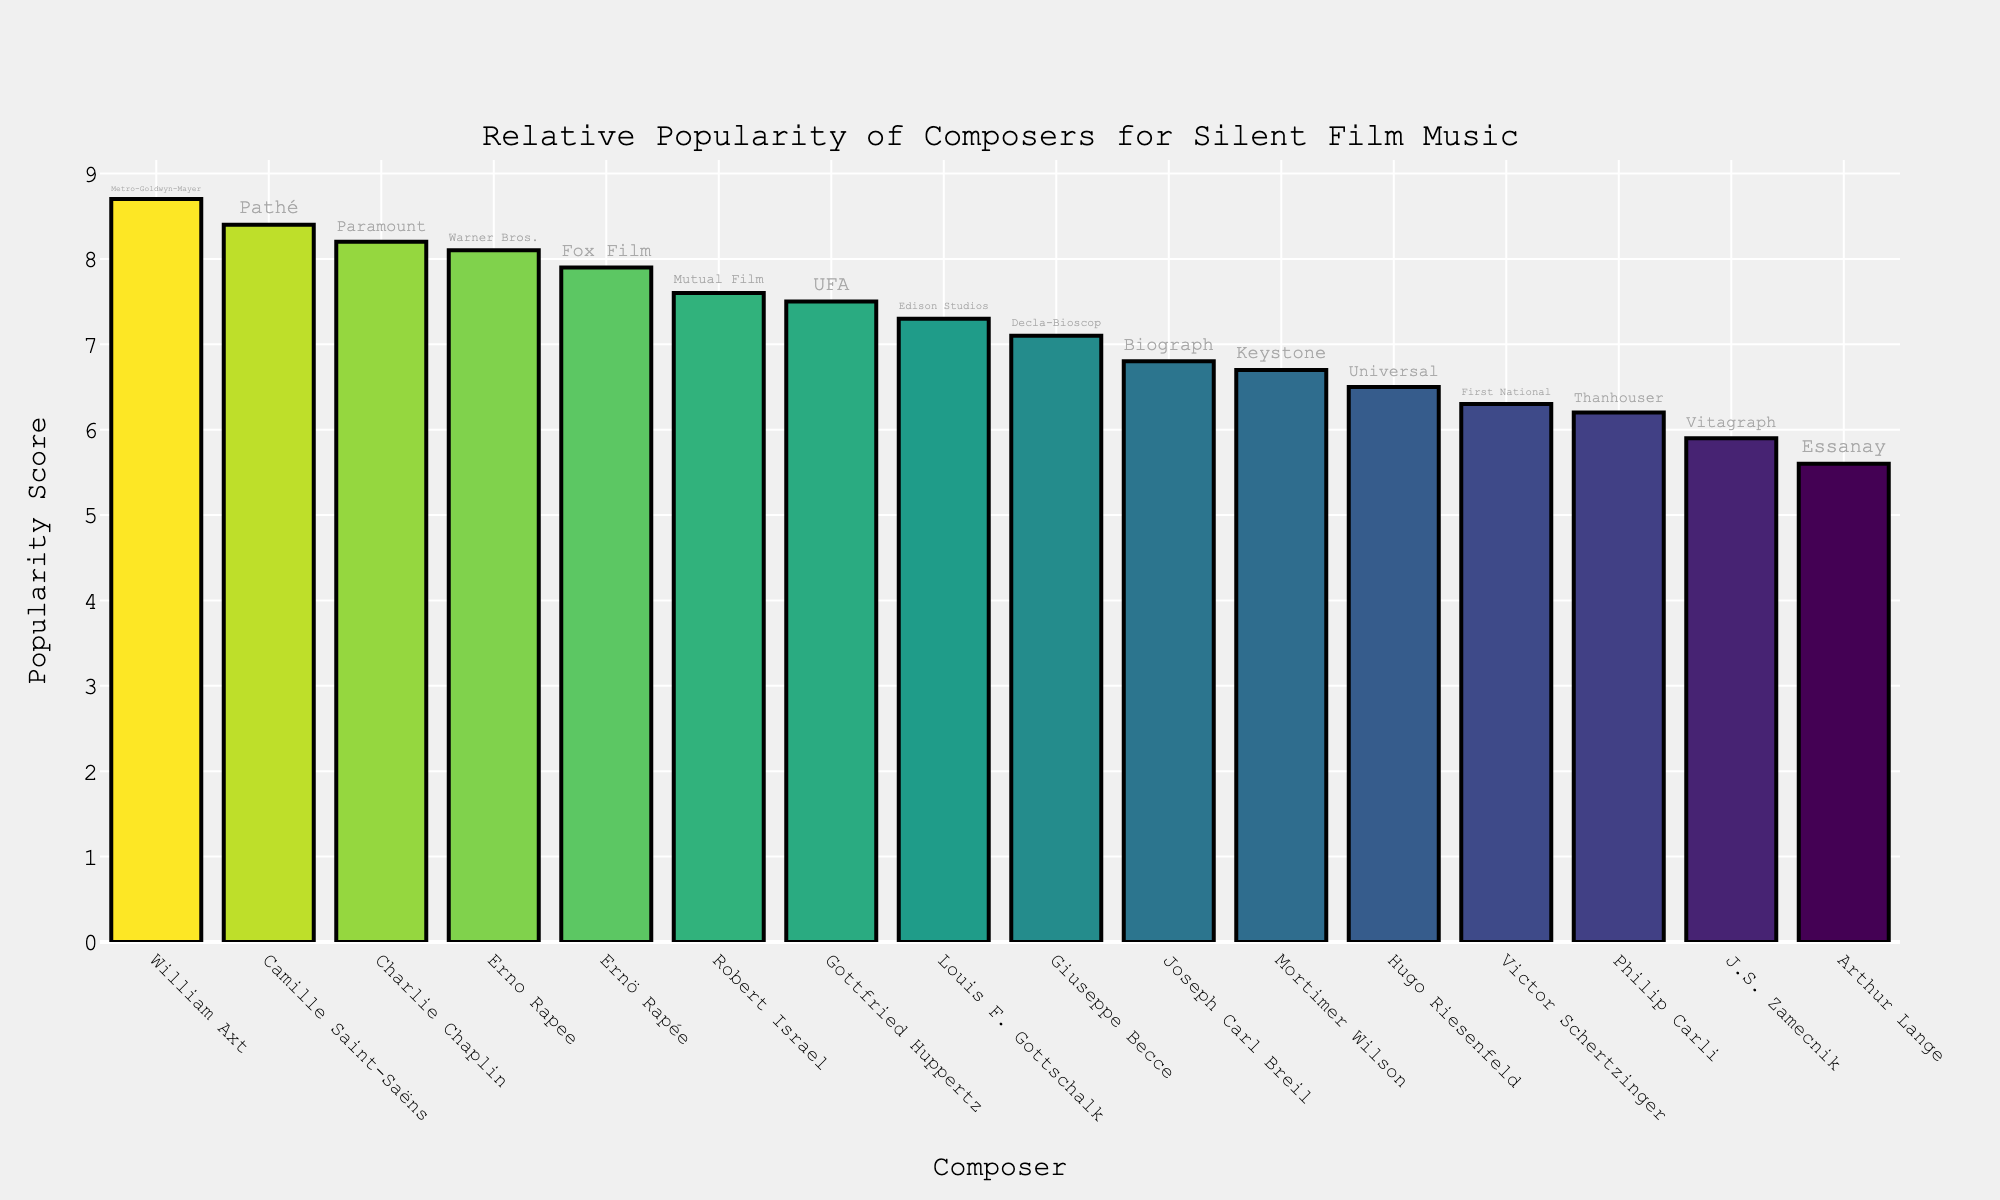What's the title of the figure? The title of the figure is typically placed at the top of the plot. In this case, it is stated within the code as "Relative Popularity of Composers for Silent Film Music".
Answer: Relative Popularity of Composers for Silent Film Music What's the highest popularity score, and which composer has it? The popularity scores are represented by the heights of the bars. The longest (tallest) bar corresponds to the highest popularity score. According to the data, William Axt has the highest score of 8.7.
Answer: William Axt, 8.7 Which studio is associated with the lowest popularity score? To determine the studio with the lowest popularity score, find the shortest bar and check its label. J.S. Zamecnik has the lowest score of 5.9, and his studio is Vitagraph.
Answer: Vitagraph How many composers have a popularity score greater than 7.0? Count the bars with heights corresponding to scores greater than 7.0. The composers with scores above 7.0 are Charlie Chaplin, Gottfried Huppertz, Ernö Rapée (Fox Film), William Axt, Giuseppe Becce, Erno Rapee (Warner Bros.), Robert Israel, and Louis F. Gottschalk, making it 8 in total.
Answer: 8 Which composer represents Pathé studio, and what is their popularity score? Locate the bar labeled "Pathé" and identify its composer and height. The composer is Camille Saint-Saëns with a score of 8.4.
Answer: Camille Saint-Saëns, 8.4 How does Hugo Riesenfeld's popularity score compare to that of Victor Schertzinger? Find the bars labeled Hugo Riesenfeld and Victor Schertzinger and compare their heights. Hugo Riesenfeld's score is 6.5, and Victor Schertzinger's score is 6.3. Since 6.5 is greater than 6.3, Hugo Riesenfeld's score is higher.
Answer: Hugo Riesenfeld's score is higher What is the median popularity score of all composers? To find the median, first sort the scores in ascending order, then find the middle value. Sorted scores: 5.6, 5.9, 6.2, 6.3, 6.5, 6.7, 6.8, 7.1, 7.3, 7.5, 7.6, 7.9, 8.1, 8.2, 8.4, 8.7. The middle values are 7.1 and 7.3, so the median is the average of these two values, (7.1 + 7.3)/2 = 7.2.
Answer: 7.2 Which composer from Warner Bros. studio has a higher popularity score than another composer with a very similar name? Compare the popularity scores of composers from Warner Bros., Erno Rapee (Warner Bros.) and Ernö Rapée (Fox Film). Though they share similar names, Erno Rapee (Warner Bros.) has a score of 8.1, while Ernö Rapée (Fox Film) has a score of 7.9.
Answer: Erno Rapee (Warner Bros.) 